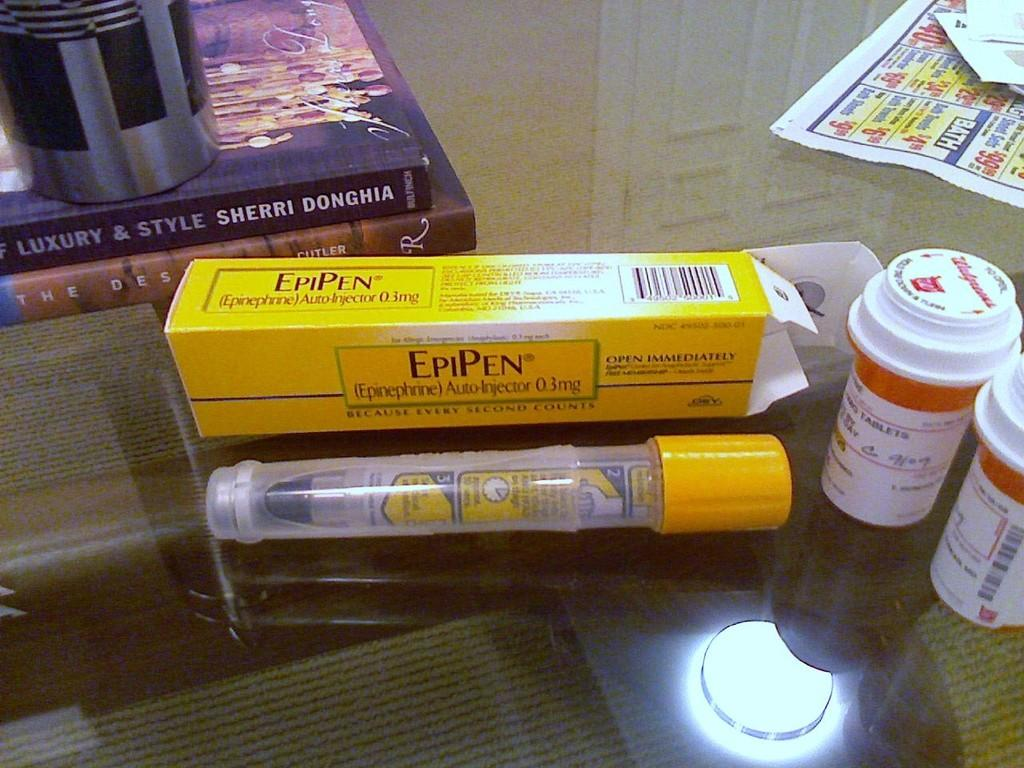<image>
Present a compact description of the photo's key features. An EpiPen sitting next to other medication bottles. 